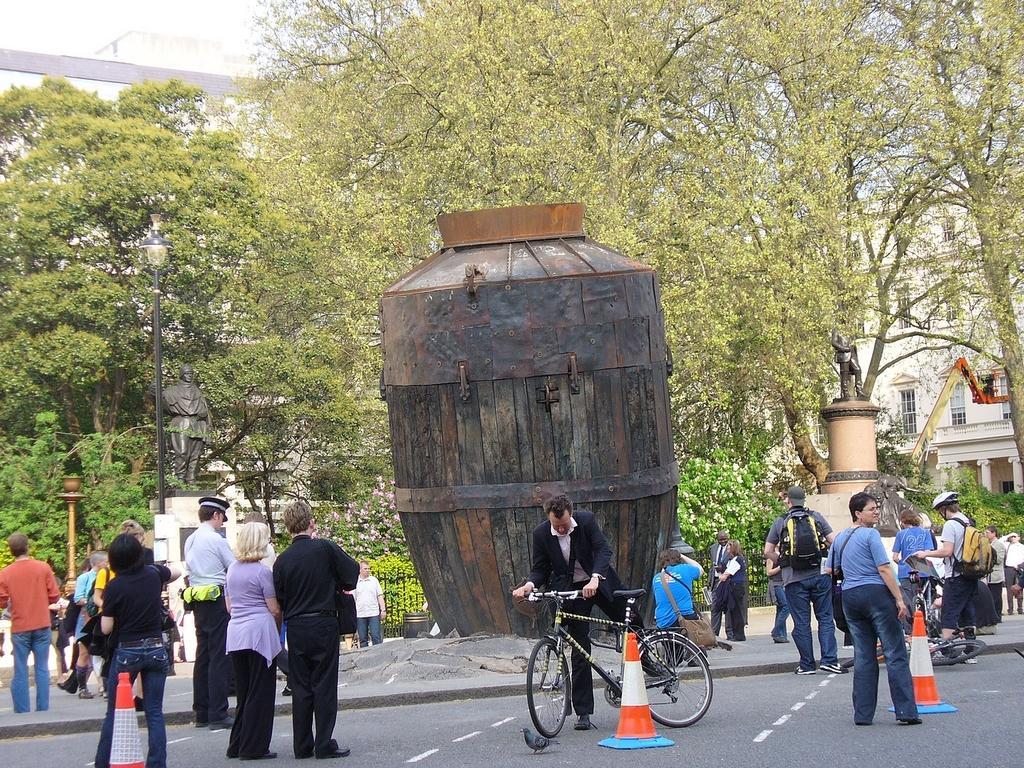In one or two sentences, can you explain what this image depicts? Here in this picture we can see many people are standing on the road. There is traffic cone. And one person is climbing the bicycle. On the footpath we can see a wooden type of hut. On the footpath the blue color t-shirt man is taking a photograph. Behind them there is a tree. There is a street light pole. To the right side we can see a building. 